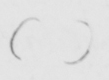Can you read and transcribe this handwriting? (   ) 